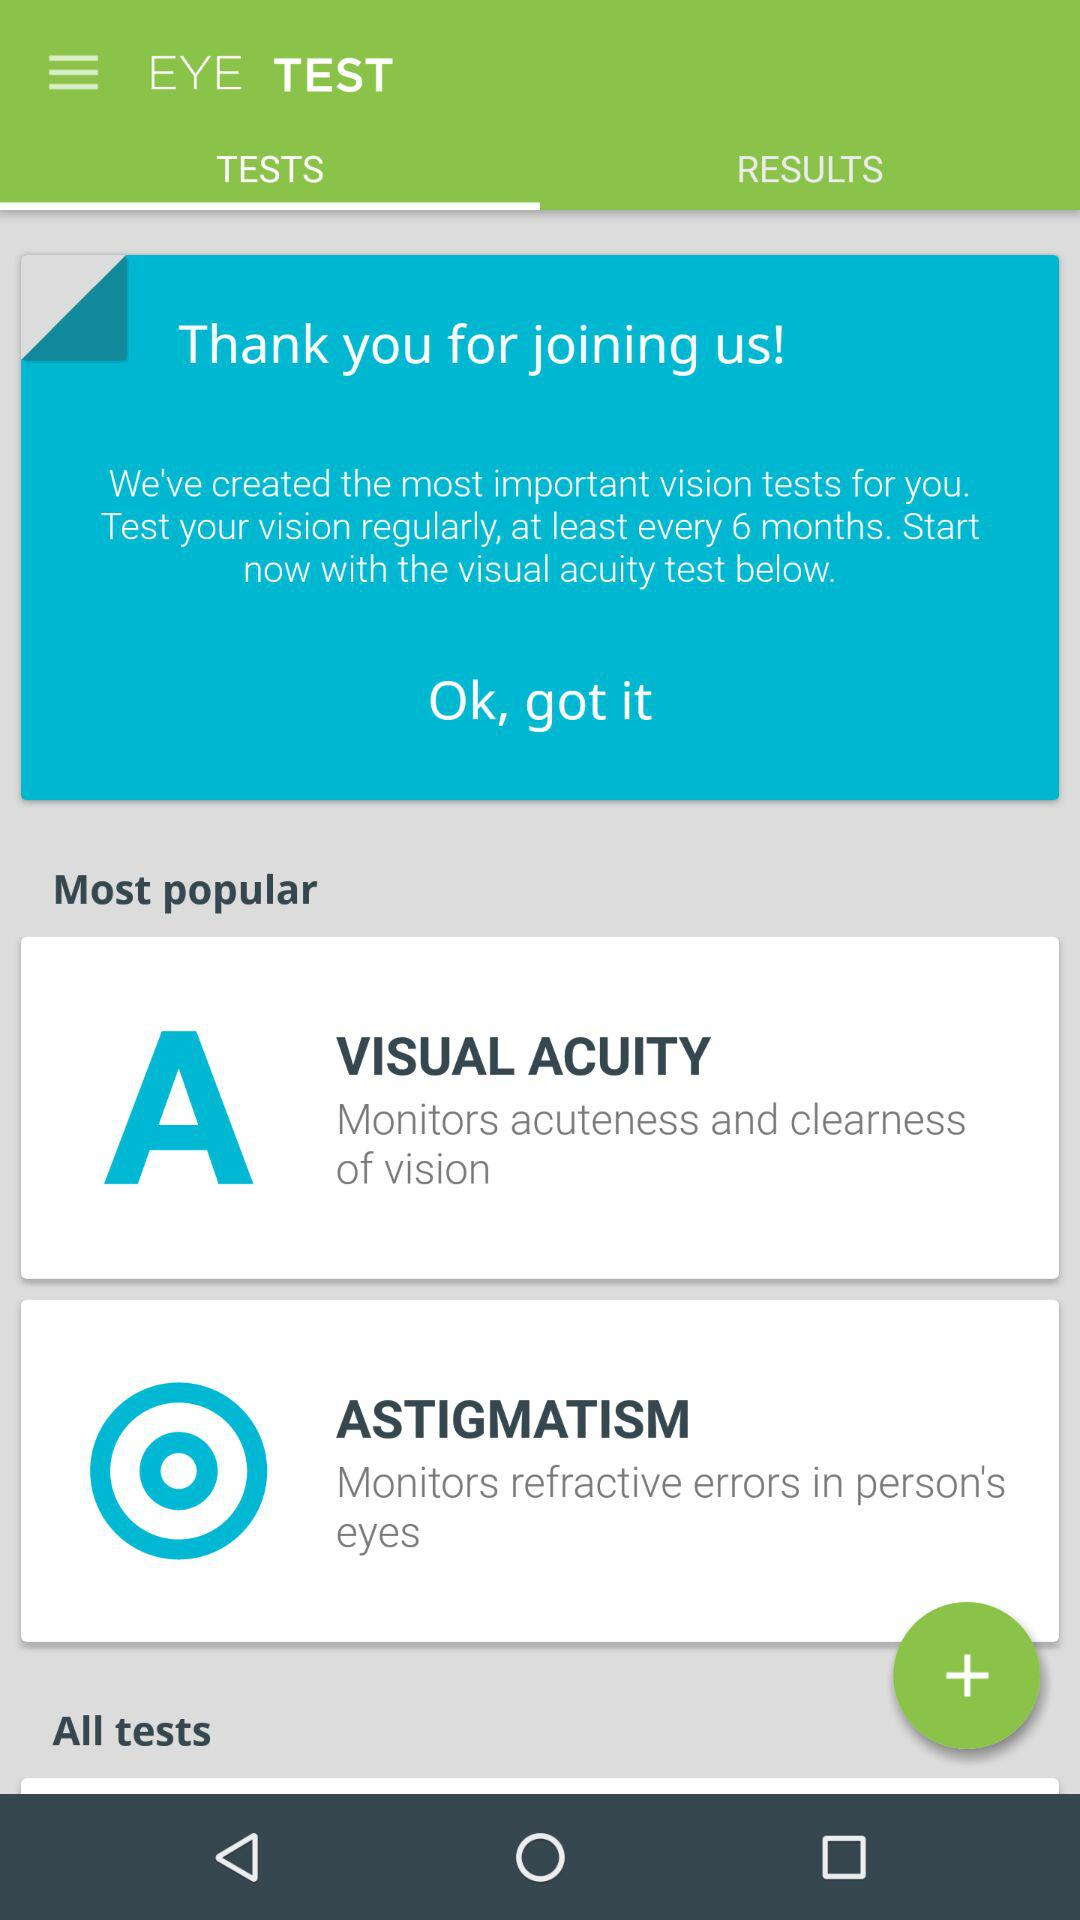What is the application name? The application name is "EYE TEST". 